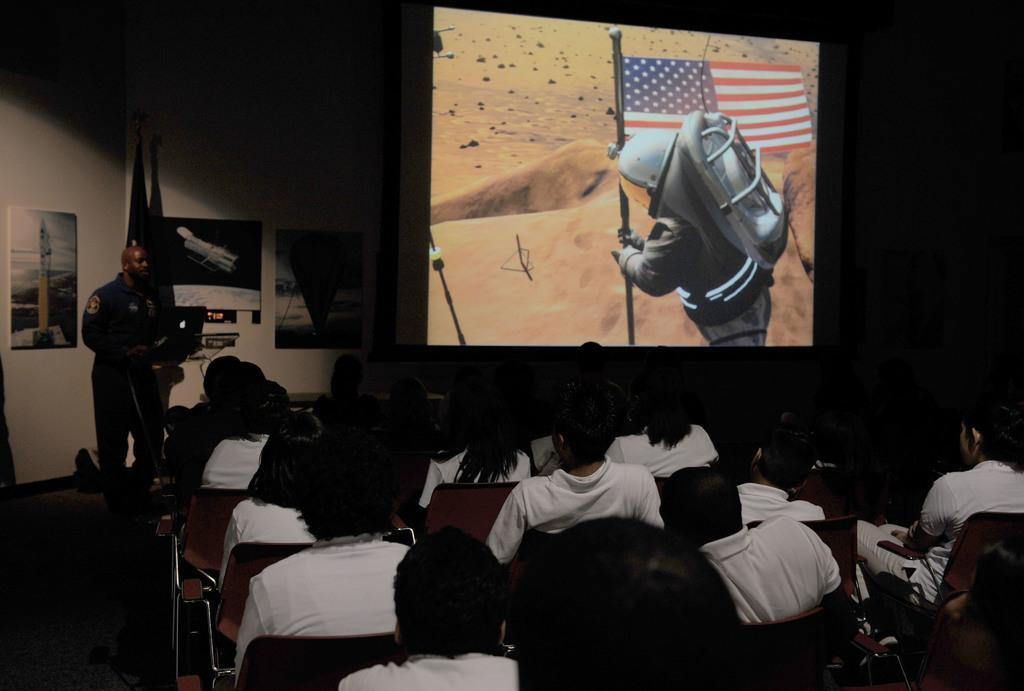How would you summarize this image in a sentence or two? In this picture I can see group of people sitting on the chairs, there is a person standing, there is a laptop on the podium, there are frames attached to the wall and there is a projector screen. 